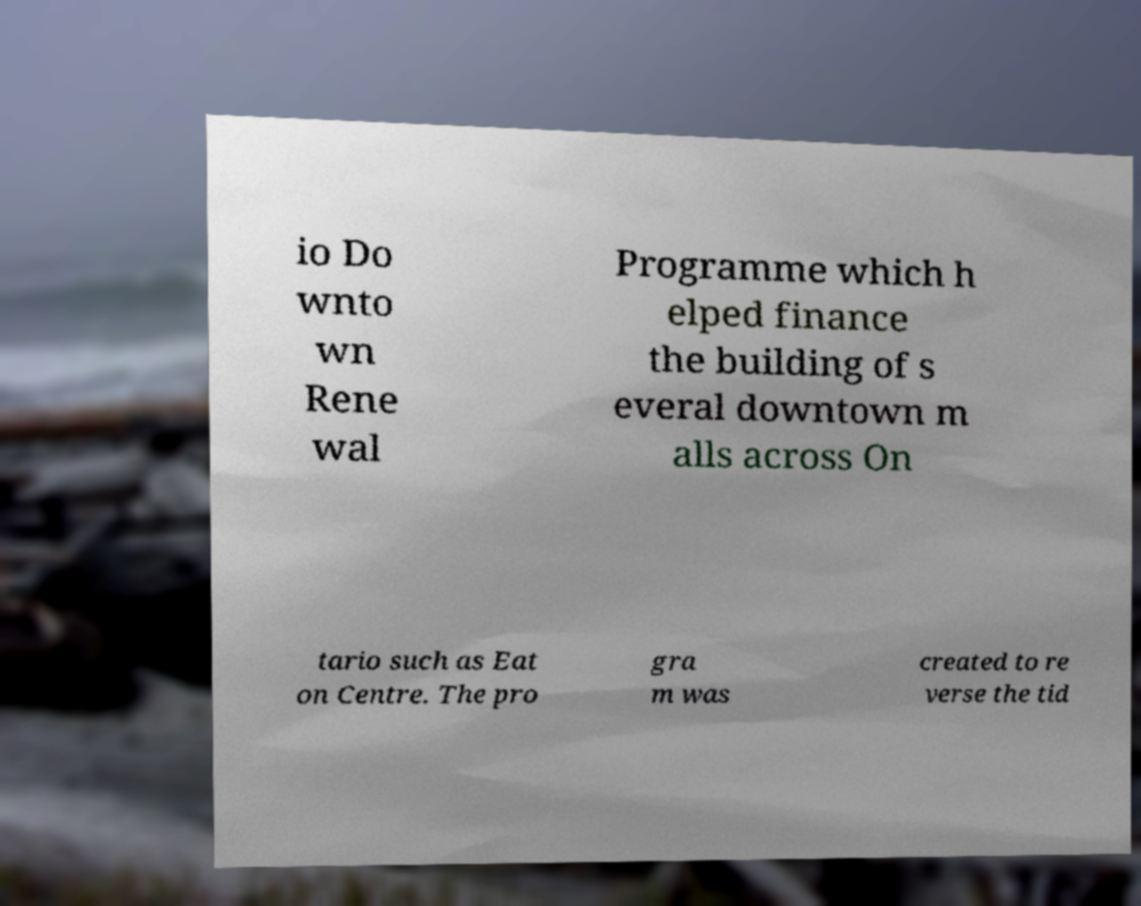Could you extract and type out the text from this image? io Do wnto wn Rene wal Programme which h elped finance the building of s everal downtown m alls across On tario such as Eat on Centre. The pro gra m was created to re verse the tid 